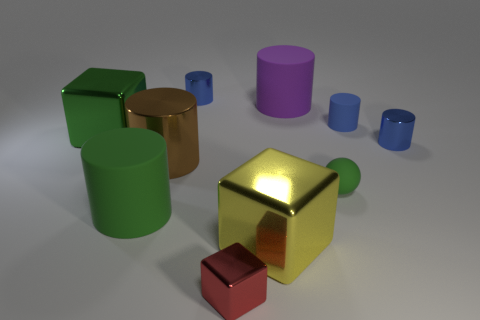What material is the small blue cylinder that is to the left of the large cylinder to the right of the big metallic thing in front of the matte ball?
Make the answer very short. Metal. What number of balls are green matte objects or brown shiny things?
Make the answer very short. 1. Is there any other thing that is the same size as the yellow shiny object?
Your answer should be compact. Yes. There is a small blue shiny object in front of the blue metallic object that is behind the big purple cylinder; how many yellow metal things are in front of it?
Make the answer very short. 1. Does the large yellow metal thing have the same shape as the small red metallic object?
Offer a very short reply. Yes. Do the big green thing that is behind the large green rubber object and the thing that is in front of the yellow shiny thing have the same material?
Give a very brief answer. Yes. How many things are either objects in front of the yellow metallic object or objects behind the tiny blue rubber object?
Offer a very short reply. 3. Are there any other things that are the same shape as the yellow metal thing?
Make the answer very short. Yes. What number of tiny blue things are there?
Keep it short and to the point. 3. Are there any red rubber cubes that have the same size as the green matte ball?
Offer a terse response. No. 